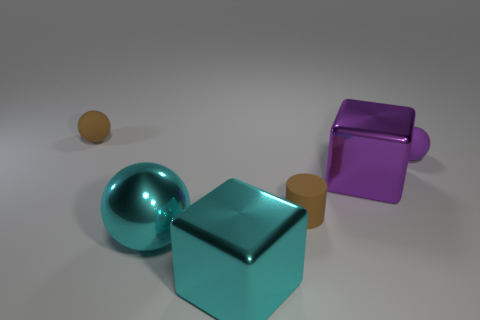Is the size of the brown thing on the left side of the matte cylinder the same as the cyan ball?
Your answer should be very brief. No. How many cyan metallic objects are there?
Provide a succinct answer. 2. What number of cubes are behind the large cyan cube and in front of the big purple thing?
Give a very brief answer. 0. Are there any brown balls made of the same material as the purple sphere?
Your answer should be very brief. Yes. The small brown object to the left of the tiny object in front of the purple ball is made of what material?
Give a very brief answer. Rubber. Are there an equal number of tiny brown matte spheres that are in front of the tiny brown cylinder and large purple metal blocks that are on the right side of the purple rubber ball?
Give a very brief answer. Yes. Do the purple metal thing and the purple matte thing have the same shape?
Ensure brevity in your answer.  No. What is the thing that is both behind the big purple shiny thing and to the right of the cyan metal ball made of?
Your answer should be compact. Rubber. What number of brown objects have the same shape as the big purple metallic object?
Offer a terse response. 0. There is a rubber ball that is on the left side of the purple object left of the tiny rubber sphere right of the cylinder; what is its size?
Make the answer very short. Small. 